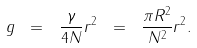Convert formula to latex. <formula><loc_0><loc_0><loc_500><loc_500>g \ = \ \frac { \gamma } { 4 N } r ^ { 2 } \ = \ \frac { \pi R ^ { 2 } } { N ^ { 2 } } r ^ { 2 } .</formula> 